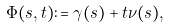<formula> <loc_0><loc_0><loc_500><loc_500>\Phi ( s , t ) \colon = \gamma ( s ) + t \nu ( s ) ,</formula> 